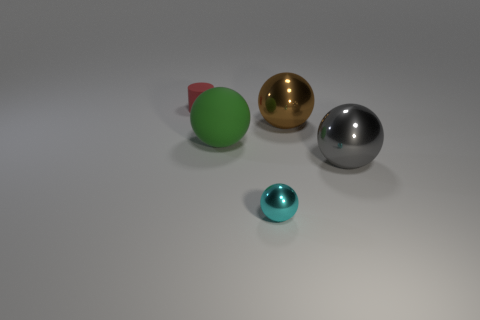Can you tell me what the silver sphere is made of and describe its surface? While I can't be certain of the material composition from an image alone, the silver sphere seems to have a highly reflective and smooth surface, indicative of a polished metal, possibly stainless steel. 